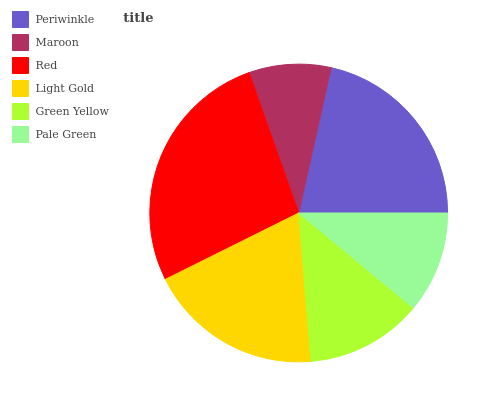Is Maroon the minimum?
Answer yes or no. Yes. Is Red the maximum?
Answer yes or no. Yes. Is Red the minimum?
Answer yes or no. No. Is Maroon the maximum?
Answer yes or no. No. Is Red greater than Maroon?
Answer yes or no. Yes. Is Maroon less than Red?
Answer yes or no. Yes. Is Maroon greater than Red?
Answer yes or no. No. Is Red less than Maroon?
Answer yes or no. No. Is Light Gold the high median?
Answer yes or no. Yes. Is Green Yellow the low median?
Answer yes or no. Yes. Is Pale Green the high median?
Answer yes or no. No. Is Red the low median?
Answer yes or no. No. 